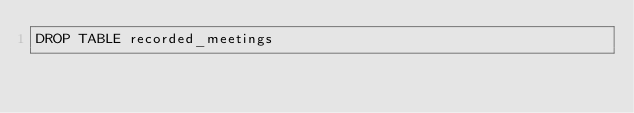Convert code to text. <code><loc_0><loc_0><loc_500><loc_500><_SQL_>DROP TABLE recorded_meetings
</code> 